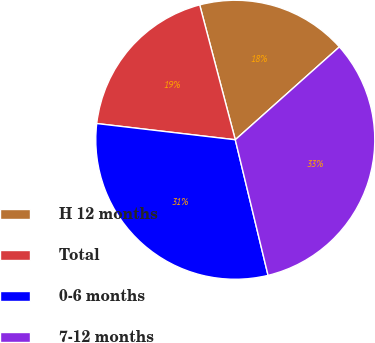Convert chart to OTSL. <chart><loc_0><loc_0><loc_500><loc_500><pie_chart><fcel>H 12 months<fcel>Total<fcel>0-6 months<fcel>7-12 months<nl><fcel>17.51%<fcel>19.04%<fcel>30.63%<fcel>32.82%<nl></chart> 